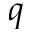<formula> <loc_0><loc_0><loc_500><loc_500>q</formula> 